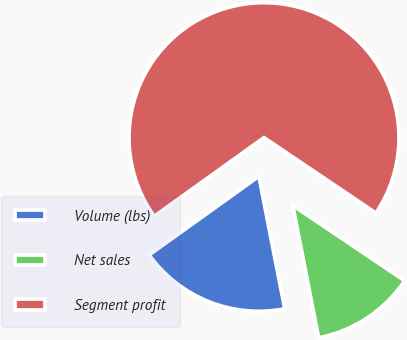Convert chart. <chart><loc_0><loc_0><loc_500><loc_500><pie_chart><fcel>Volume (lbs)<fcel>Net sales<fcel>Segment profit<nl><fcel>18.18%<fcel>12.49%<fcel>69.33%<nl></chart> 